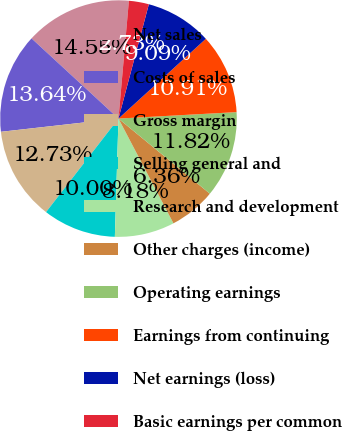Convert chart to OTSL. <chart><loc_0><loc_0><loc_500><loc_500><pie_chart><fcel>Net sales<fcel>Costs of sales<fcel>Gross margin<fcel>Selling general and<fcel>Research and development<fcel>Other charges (income)<fcel>Operating earnings<fcel>Earnings from continuing<fcel>Net earnings (loss)<fcel>Basic earnings per common<nl><fcel>14.55%<fcel>13.64%<fcel>12.73%<fcel>10.0%<fcel>8.18%<fcel>6.36%<fcel>11.82%<fcel>10.91%<fcel>9.09%<fcel>2.73%<nl></chart> 